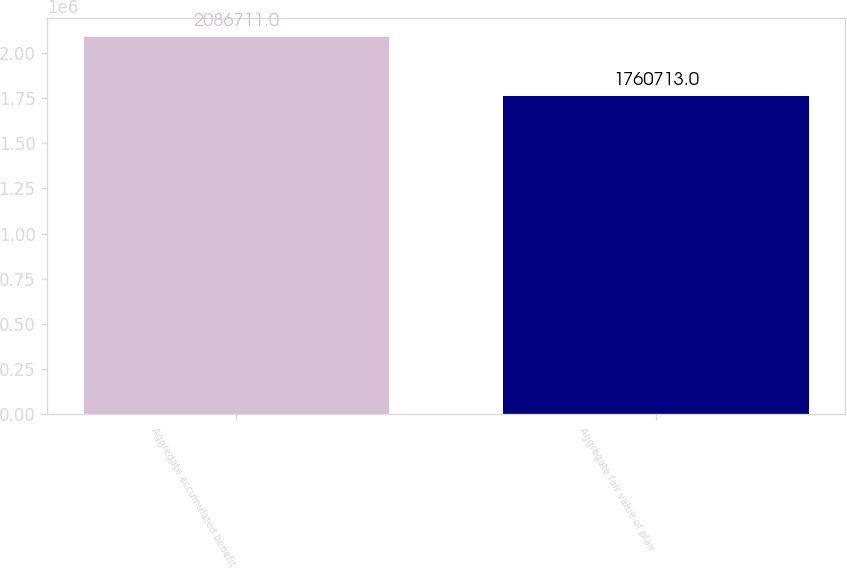Convert chart. <chart><loc_0><loc_0><loc_500><loc_500><bar_chart><fcel>Aggregate accumulated benefit<fcel>Aggregate fair value of plan<nl><fcel>2.08671e+06<fcel>1.76071e+06<nl></chart> 